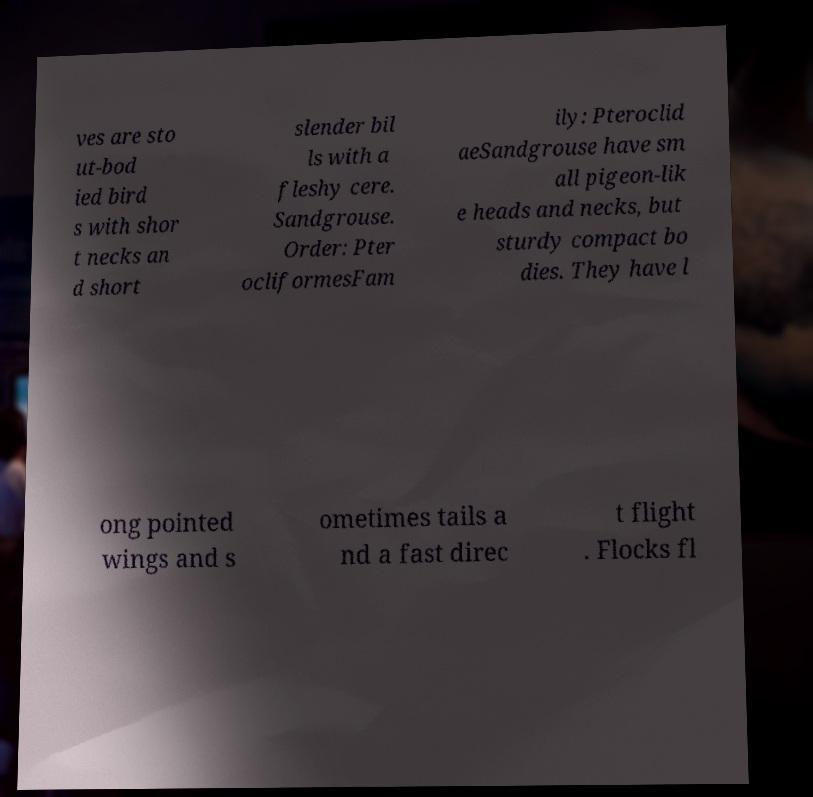I need the written content from this picture converted into text. Can you do that? ves are sto ut-bod ied bird s with shor t necks an d short slender bil ls with a fleshy cere. Sandgrouse. Order: Pter ocliformesFam ily: Pteroclid aeSandgrouse have sm all pigeon-lik e heads and necks, but sturdy compact bo dies. They have l ong pointed wings and s ometimes tails a nd a fast direc t flight . Flocks fl 